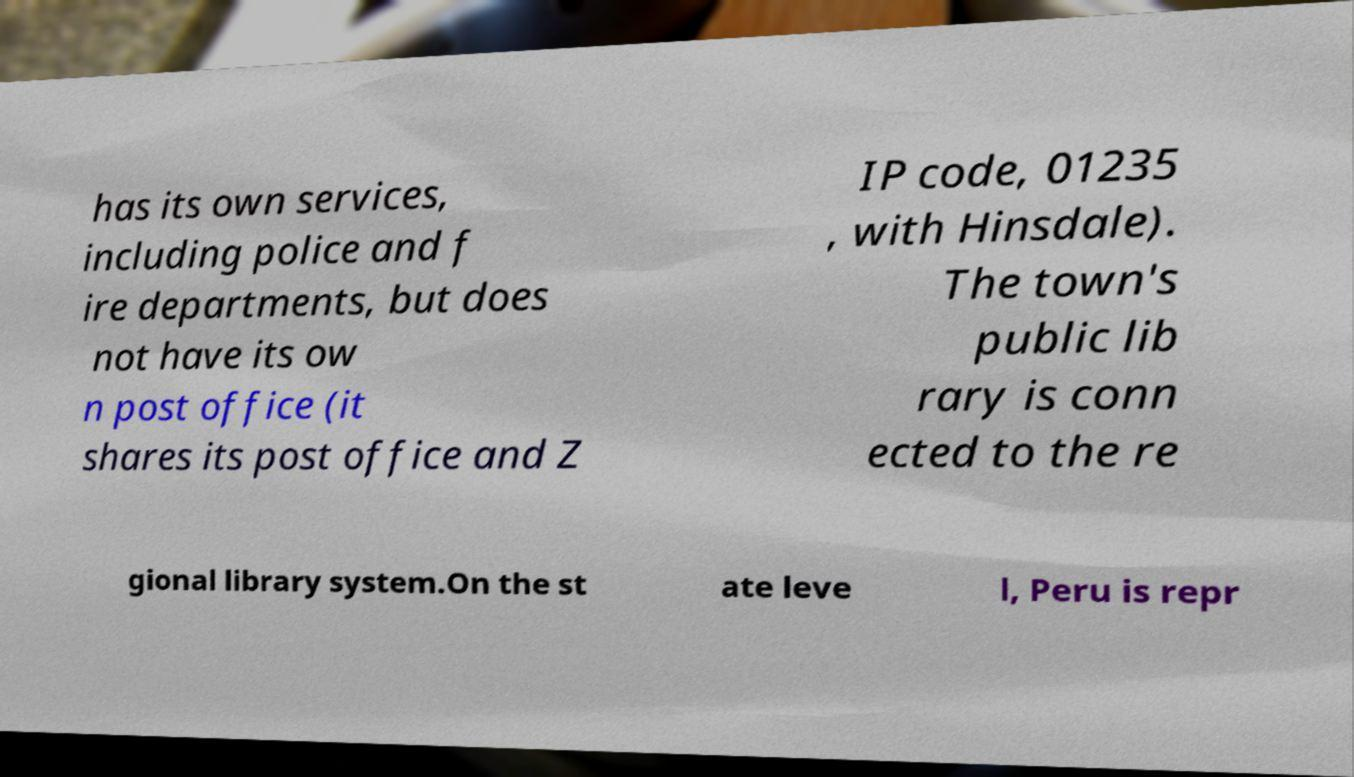What messages or text are displayed in this image? I need them in a readable, typed format. has its own services, including police and f ire departments, but does not have its ow n post office (it shares its post office and Z IP code, 01235 , with Hinsdale). The town's public lib rary is conn ected to the re gional library system.On the st ate leve l, Peru is repr 